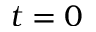Convert formula to latex. <formula><loc_0><loc_0><loc_500><loc_500>t = 0</formula> 